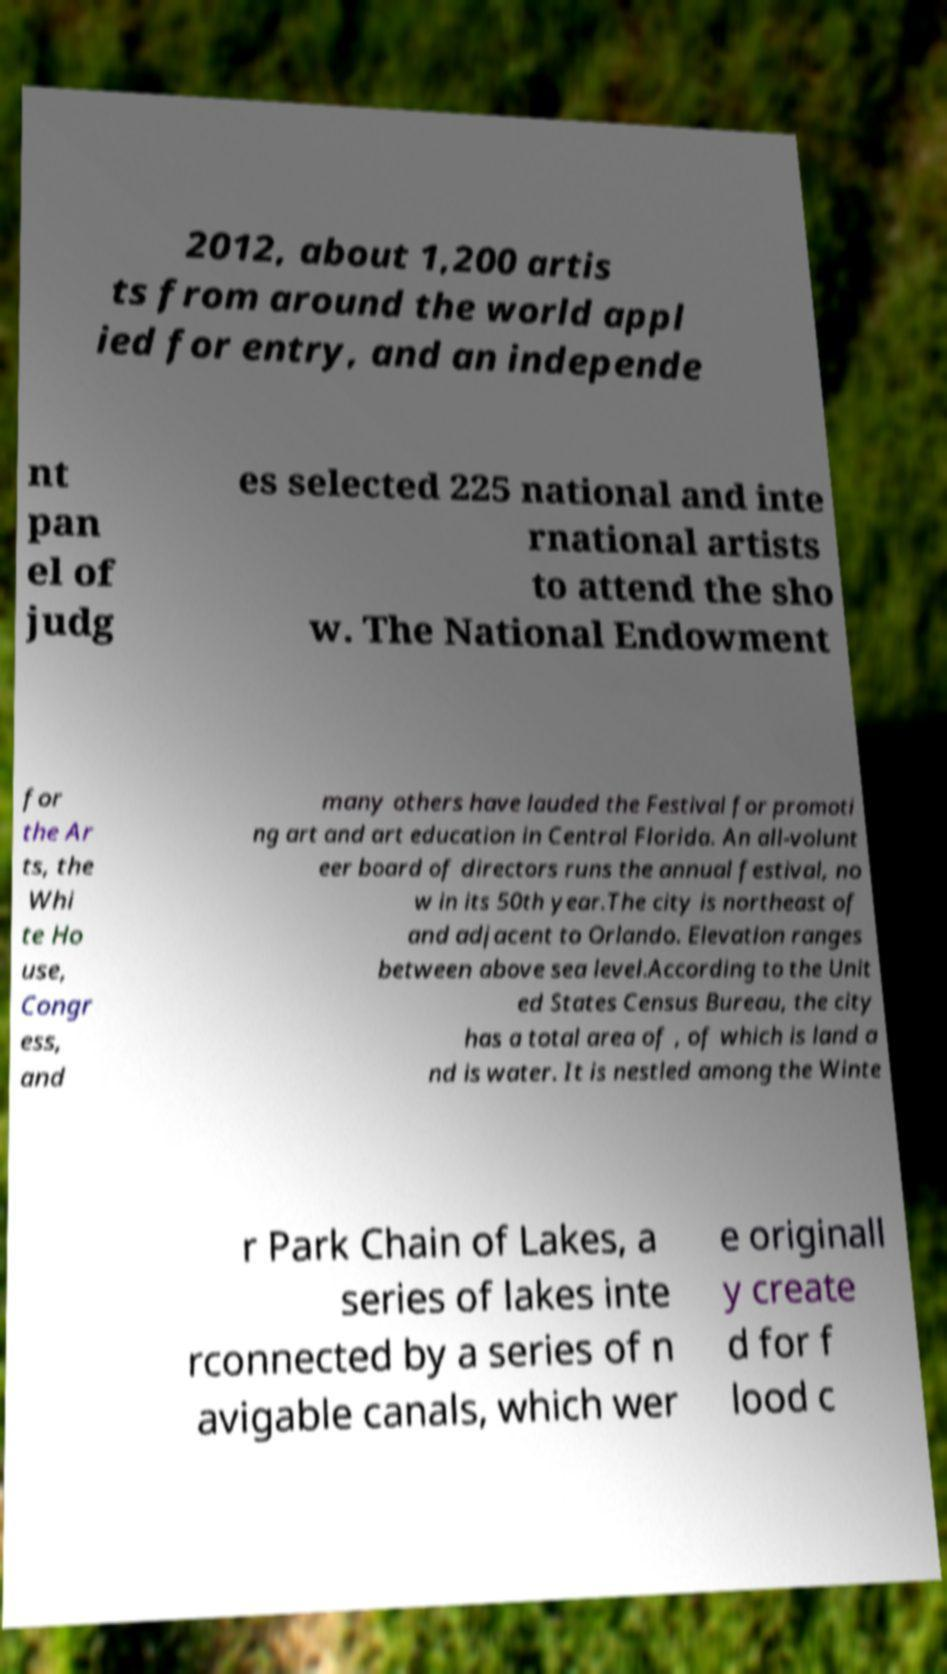Can you accurately transcribe the text from the provided image for me? 2012, about 1,200 artis ts from around the world appl ied for entry, and an independe nt pan el of judg es selected 225 national and inte rnational artists to attend the sho w. The National Endowment for the Ar ts, the Whi te Ho use, Congr ess, and many others have lauded the Festival for promoti ng art and art education in Central Florida. An all-volunt eer board of directors runs the annual festival, no w in its 50th year.The city is northeast of and adjacent to Orlando. Elevation ranges between above sea level.According to the Unit ed States Census Bureau, the city has a total area of , of which is land a nd is water. It is nestled among the Winte r Park Chain of Lakes, a series of lakes inte rconnected by a series of n avigable canals, which wer e originall y create d for f lood c 